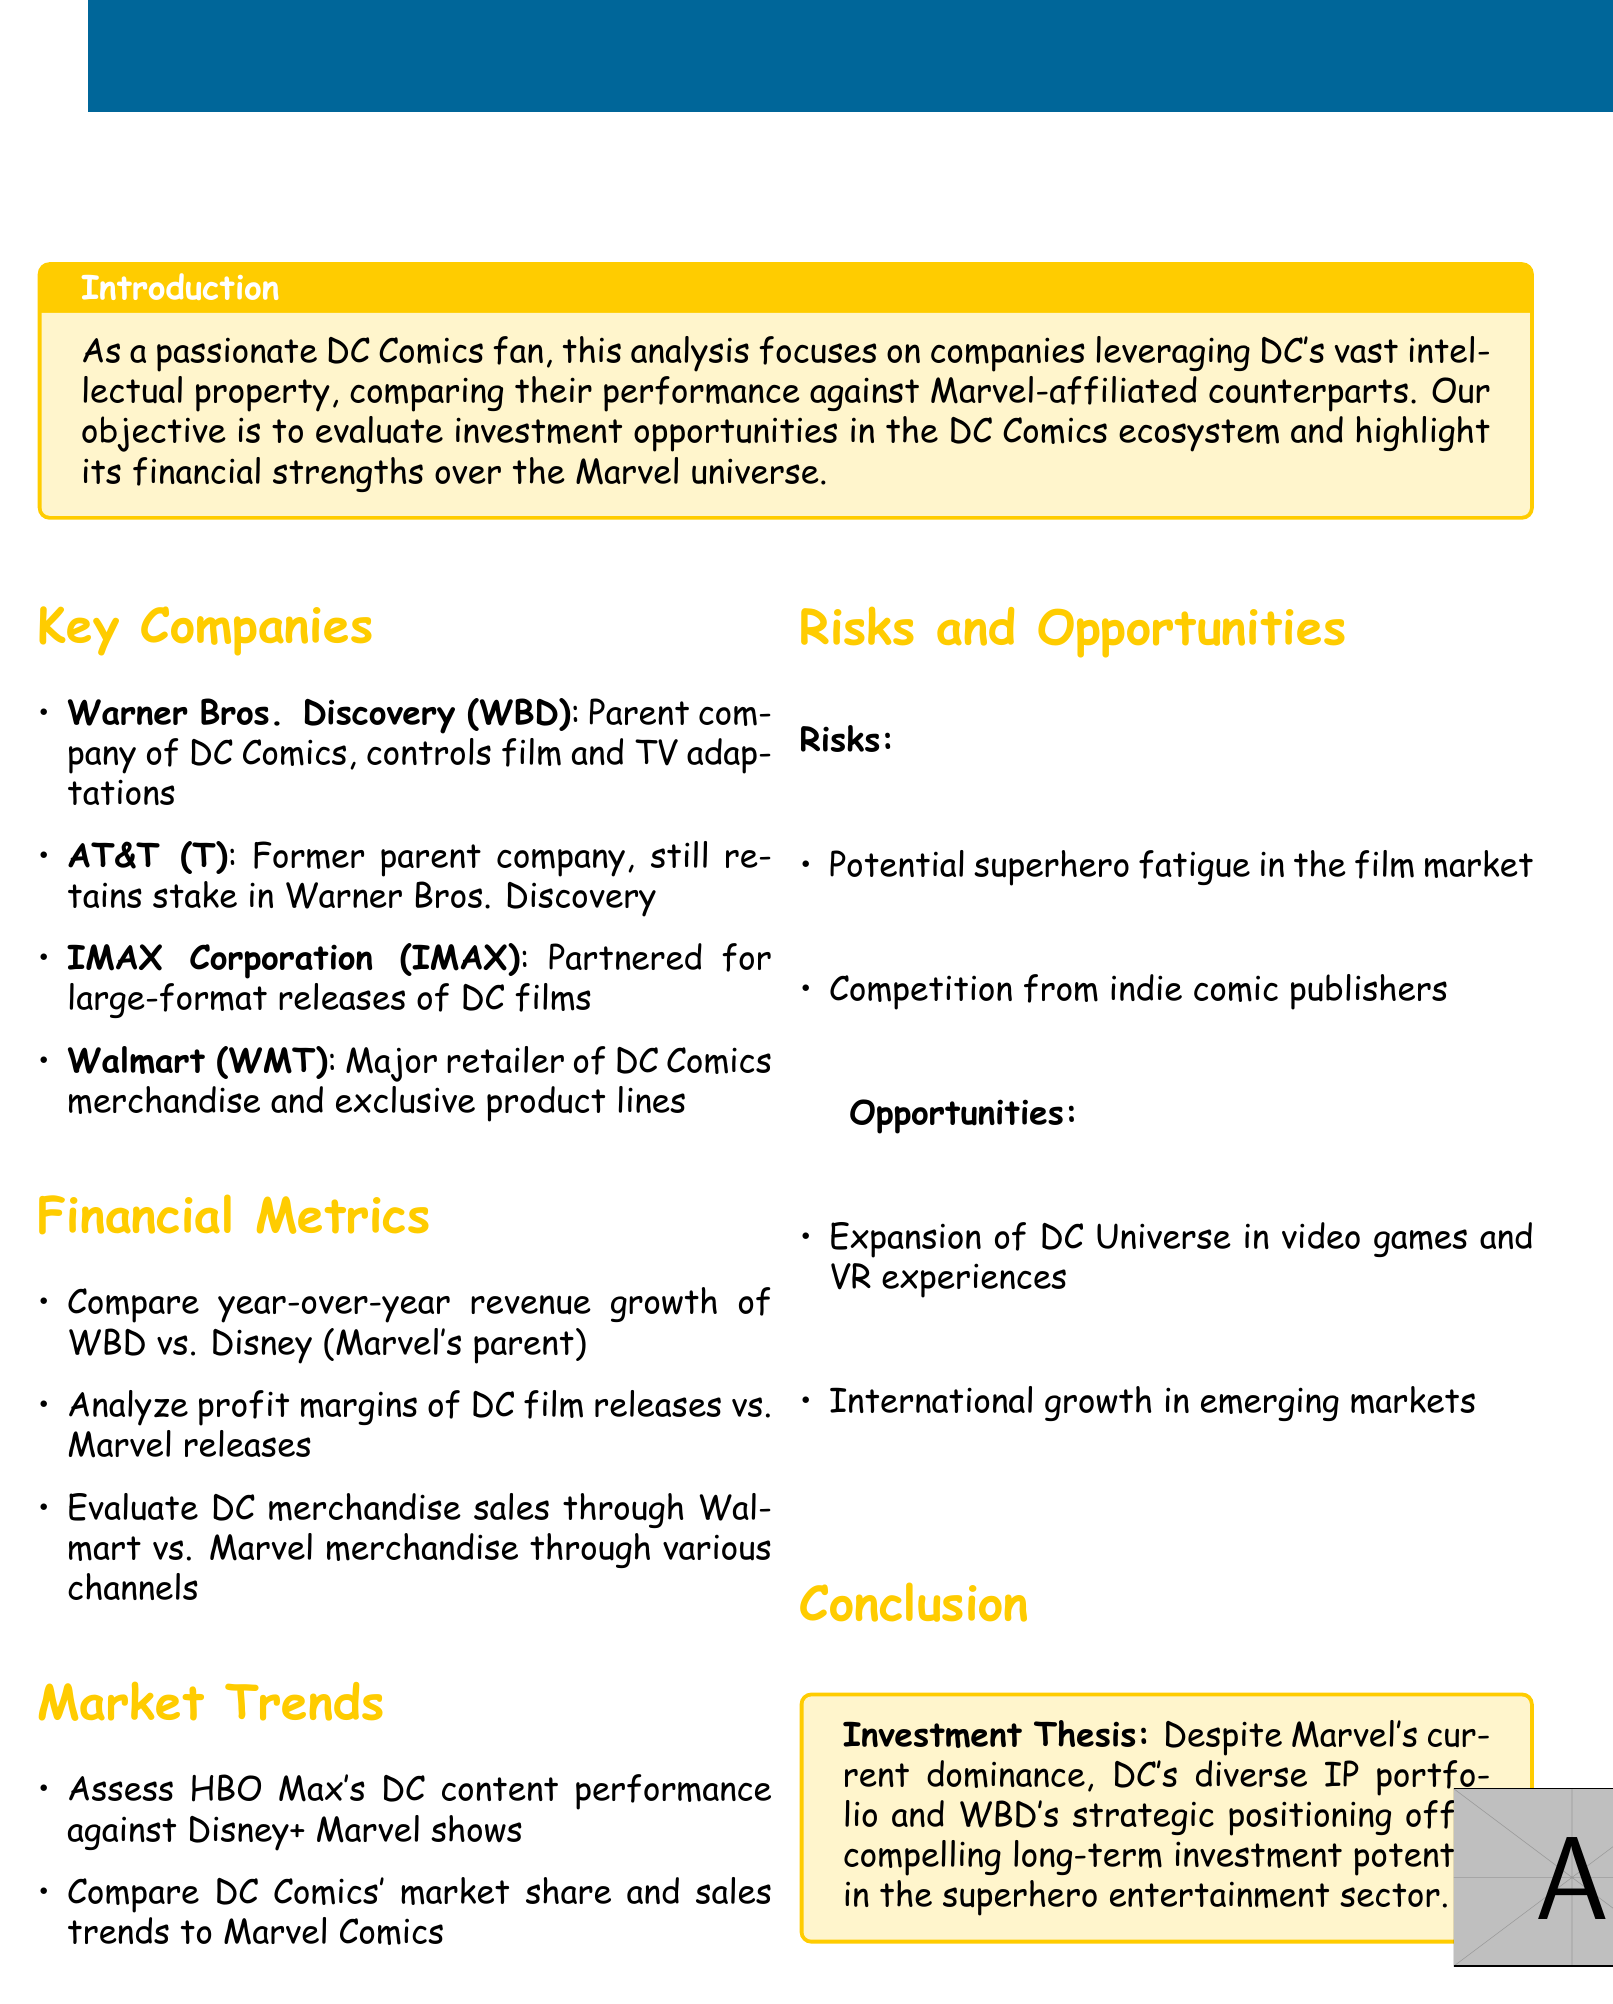What is the title of the document? The title is provided at the beginning of the document and captures the focus of the analysis.
Answer: Investment Portfolio Analysis: DC Comics IP-Related Companies Who is the parent company of DC Comics? This information is found in the Key Companies section, detailing the main company responsible for DC Comics.
Answer: Warner Bros. Discovery What company remains a stakeholder in Warner Bros. Discovery? This information is found under Key Companies, identifying a former parent company that still holds a stake.
Answer: AT&T What is one of the financial metrics being analyzed? The document outlines various financial metrics that are being discussed for comparison.
Answer: Profit margins What streaming service's DC content is compared against Disney+? This comparison is stated in the Market Trends section, focusing on content performance evaluation.
Answer: HBO Max What are two identified risks in the document? The Risks and Opportunities section lists potential challenges the companies face regarding the superhero market.
Answer: Superhero fatigue, competition from indie comic publishers What is one opportunity listed for DC Comics? The opportunities for growth and expansion are provided in the Risks and Opportunities portion.
Answer: Expansion of DC Universe in video games and VR experiences What is the investment thesis conclusion mentioned? The conclusion summarizes the overall investment perspective derived from the analysis.
Answer: Compelling long-term investment potential in the superhero entertainment sector Which company conducts large-format releases for DC films? This detail is provided in the Key Companies section, highlighting partnerships for specific film formats.
Answer: IMAX Corporation 